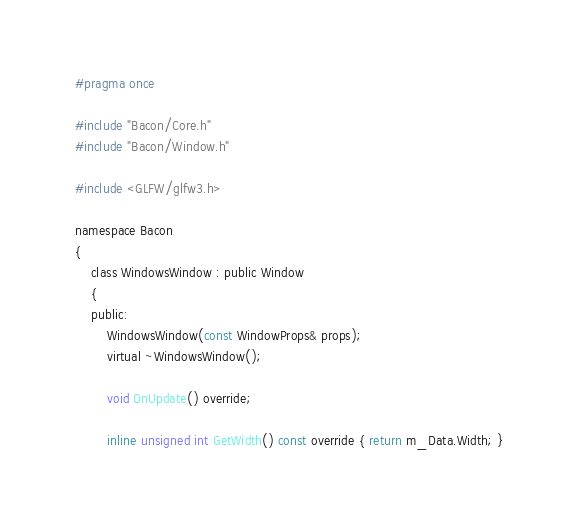<code> <loc_0><loc_0><loc_500><loc_500><_C_>#pragma once

#include "Bacon/Core.h"
#include "Bacon/Window.h"

#include <GLFW/glfw3.h>

namespace Bacon
{
	class WindowsWindow : public Window
	{
	public:
		WindowsWindow(const WindowProps& props);
		virtual ~WindowsWindow();

		void OnUpdate() override;

		inline unsigned int GetWidth() const override { return m_Data.Width; }</code> 